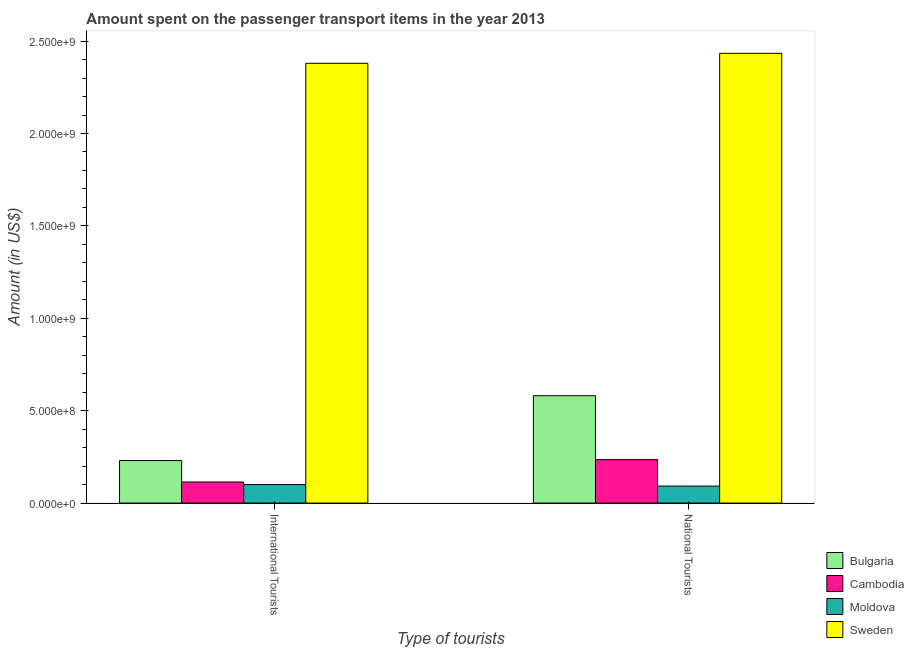How many different coloured bars are there?
Give a very brief answer. 4. Are the number of bars per tick equal to the number of legend labels?
Offer a terse response. Yes. Are the number of bars on each tick of the X-axis equal?
Give a very brief answer. Yes. How many bars are there on the 2nd tick from the left?
Offer a terse response. 4. What is the label of the 1st group of bars from the left?
Your answer should be very brief. International Tourists. What is the amount spent on transport items of international tourists in Bulgaria?
Offer a terse response. 2.30e+08. Across all countries, what is the maximum amount spent on transport items of international tourists?
Make the answer very short. 2.38e+09. Across all countries, what is the minimum amount spent on transport items of national tourists?
Make the answer very short. 9.20e+07. In which country was the amount spent on transport items of international tourists minimum?
Your answer should be compact. Moldova. What is the total amount spent on transport items of national tourists in the graph?
Offer a terse response. 3.34e+09. What is the difference between the amount spent on transport items of national tourists in Moldova and that in Bulgaria?
Your answer should be very brief. -4.89e+08. What is the difference between the amount spent on transport items of national tourists in Moldova and the amount spent on transport items of international tourists in Cambodia?
Your answer should be compact. -2.20e+07. What is the average amount spent on transport items of national tourists per country?
Ensure brevity in your answer.  8.36e+08. What is the difference between the amount spent on transport items of national tourists and amount spent on transport items of international tourists in Bulgaria?
Your answer should be compact. 3.51e+08. What is the ratio of the amount spent on transport items of international tourists in Cambodia to that in Moldova?
Your answer should be very brief. 1.14. Is the amount spent on transport items of national tourists in Cambodia less than that in Sweden?
Offer a very short reply. Yes. In how many countries, is the amount spent on transport items of international tourists greater than the average amount spent on transport items of international tourists taken over all countries?
Make the answer very short. 1. What does the 4th bar from the right in International Tourists represents?
Ensure brevity in your answer.  Bulgaria. How many bars are there?
Your response must be concise. 8. How many countries are there in the graph?
Offer a very short reply. 4. Are the values on the major ticks of Y-axis written in scientific E-notation?
Your response must be concise. Yes. How are the legend labels stacked?
Make the answer very short. Vertical. What is the title of the graph?
Keep it short and to the point. Amount spent on the passenger transport items in the year 2013. Does "Ireland" appear as one of the legend labels in the graph?
Give a very brief answer. No. What is the label or title of the X-axis?
Provide a short and direct response. Type of tourists. What is the Amount (in US$) of Bulgaria in International Tourists?
Offer a very short reply. 2.30e+08. What is the Amount (in US$) in Cambodia in International Tourists?
Your response must be concise. 1.14e+08. What is the Amount (in US$) of Sweden in International Tourists?
Ensure brevity in your answer.  2.38e+09. What is the Amount (in US$) of Bulgaria in National Tourists?
Make the answer very short. 5.81e+08. What is the Amount (in US$) in Cambodia in National Tourists?
Your answer should be compact. 2.35e+08. What is the Amount (in US$) of Moldova in National Tourists?
Offer a very short reply. 9.20e+07. What is the Amount (in US$) of Sweden in National Tourists?
Your response must be concise. 2.43e+09. Across all Type of tourists, what is the maximum Amount (in US$) of Bulgaria?
Make the answer very short. 5.81e+08. Across all Type of tourists, what is the maximum Amount (in US$) of Cambodia?
Keep it short and to the point. 2.35e+08. Across all Type of tourists, what is the maximum Amount (in US$) in Sweden?
Make the answer very short. 2.43e+09. Across all Type of tourists, what is the minimum Amount (in US$) in Bulgaria?
Give a very brief answer. 2.30e+08. Across all Type of tourists, what is the minimum Amount (in US$) of Cambodia?
Ensure brevity in your answer.  1.14e+08. Across all Type of tourists, what is the minimum Amount (in US$) in Moldova?
Your answer should be compact. 9.20e+07. Across all Type of tourists, what is the minimum Amount (in US$) of Sweden?
Keep it short and to the point. 2.38e+09. What is the total Amount (in US$) of Bulgaria in the graph?
Make the answer very short. 8.11e+08. What is the total Amount (in US$) in Cambodia in the graph?
Your answer should be very brief. 3.49e+08. What is the total Amount (in US$) of Moldova in the graph?
Your response must be concise. 1.92e+08. What is the total Amount (in US$) in Sweden in the graph?
Provide a succinct answer. 4.81e+09. What is the difference between the Amount (in US$) in Bulgaria in International Tourists and that in National Tourists?
Provide a short and direct response. -3.51e+08. What is the difference between the Amount (in US$) in Cambodia in International Tourists and that in National Tourists?
Provide a short and direct response. -1.21e+08. What is the difference between the Amount (in US$) in Sweden in International Tourists and that in National Tourists?
Ensure brevity in your answer.  -5.40e+07. What is the difference between the Amount (in US$) in Bulgaria in International Tourists and the Amount (in US$) in Cambodia in National Tourists?
Give a very brief answer. -5.00e+06. What is the difference between the Amount (in US$) of Bulgaria in International Tourists and the Amount (in US$) of Moldova in National Tourists?
Offer a very short reply. 1.38e+08. What is the difference between the Amount (in US$) of Bulgaria in International Tourists and the Amount (in US$) of Sweden in National Tourists?
Your response must be concise. -2.20e+09. What is the difference between the Amount (in US$) of Cambodia in International Tourists and the Amount (in US$) of Moldova in National Tourists?
Ensure brevity in your answer.  2.20e+07. What is the difference between the Amount (in US$) of Cambodia in International Tourists and the Amount (in US$) of Sweden in National Tourists?
Offer a very short reply. -2.32e+09. What is the difference between the Amount (in US$) of Moldova in International Tourists and the Amount (in US$) of Sweden in National Tourists?
Make the answer very short. -2.33e+09. What is the average Amount (in US$) in Bulgaria per Type of tourists?
Give a very brief answer. 4.06e+08. What is the average Amount (in US$) in Cambodia per Type of tourists?
Your answer should be very brief. 1.74e+08. What is the average Amount (in US$) in Moldova per Type of tourists?
Offer a very short reply. 9.60e+07. What is the average Amount (in US$) of Sweden per Type of tourists?
Make the answer very short. 2.41e+09. What is the difference between the Amount (in US$) in Bulgaria and Amount (in US$) in Cambodia in International Tourists?
Ensure brevity in your answer.  1.16e+08. What is the difference between the Amount (in US$) in Bulgaria and Amount (in US$) in Moldova in International Tourists?
Give a very brief answer. 1.30e+08. What is the difference between the Amount (in US$) of Bulgaria and Amount (in US$) of Sweden in International Tourists?
Give a very brief answer. -2.15e+09. What is the difference between the Amount (in US$) in Cambodia and Amount (in US$) in Moldova in International Tourists?
Your answer should be very brief. 1.40e+07. What is the difference between the Amount (in US$) in Cambodia and Amount (in US$) in Sweden in International Tourists?
Ensure brevity in your answer.  -2.27e+09. What is the difference between the Amount (in US$) in Moldova and Amount (in US$) in Sweden in International Tourists?
Provide a short and direct response. -2.28e+09. What is the difference between the Amount (in US$) in Bulgaria and Amount (in US$) in Cambodia in National Tourists?
Offer a very short reply. 3.46e+08. What is the difference between the Amount (in US$) in Bulgaria and Amount (in US$) in Moldova in National Tourists?
Give a very brief answer. 4.89e+08. What is the difference between the Amount (in US$) of Bulgaria and Amount (in US$) of Sweden in National Tourists?
Give a very brief answer. -1.85e+09. What is the difference between the Amount (in US$) in Cambodia and Amount (in US$) in Moldova in National Tourists?
Offer a very short reply. 1.43e+08. What is the difference between the Amount (in US$) of Cambodia and Amount (in US$) of Sweden in National Tourists?
Keep it short and to the point. -2.20e+09. What is the difference between the Amount (in US$) in Moldova and Amount (in US$) in Sweden in National Tourists?
Offer a terse response. -2.34e+09. What is the ratio of the Amount (in US$) of Bulgaria in International Tourists to that in National Tourists?
Ensure brevity in your answer.  0.4. What is the ratio of the Amount (in US$) of Cambodia in International Tourists to that in National Tourists?
Provide a short and direct response. 0.49. What is the ratio of the Amount (in US$) in Moldova in International Tourists to that in National Tourists?
Make the answer very short. 1.09. What is the ratio of the Amount (in US$) of Sweden in International Tourists to that in National Tourists?
Keep it short and to the point. 0.98. What is the difference between the highest and the second highest Amount (in US$) in Bulgaria?
Your response must be concise. 3.51e+08. What is the difference between the highest and the second highest Amount (in US$) in Cambodia?
Offer a very short reply. 1.21e+08. What is the difference between the highest and the second highest Amount (in US$) of Moldova?
Your answer should be compact. 8.00e+06. What is the difference between the highest and the second highest Amount (in US$) of Sweden?
Keep it short and to the point. 5.40e+07. What is the difference between the highest and the lowest Amount (in US$) in Bulgaria?
Provide a succinct answer. 3.51e+08. What is the difference between the highest and the lowest Amount (in US$) in Cambodia?
Give a very brief answer. 1.21e+08. What is the difference between the highest and the lowest Amount (in US$) in Moldova?
Offer a very short reply. 8.00e+06. What is the difference between the highest and the lowest Amount (in US$) of Sweden?
Provide a succinct answer. 5.40e+07. 